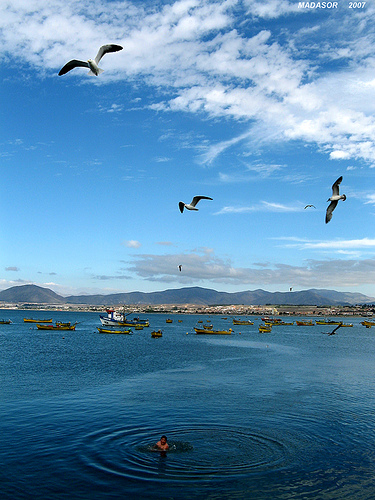What activities might be occurring on these boats? Given the serene setting, the boats are likely used for leisurely fishing or may simply be moored for the day, awaiting their owners' return to engage in various sea-related tasks, perhaps as part of a daily routine or commercial fishing operation. 